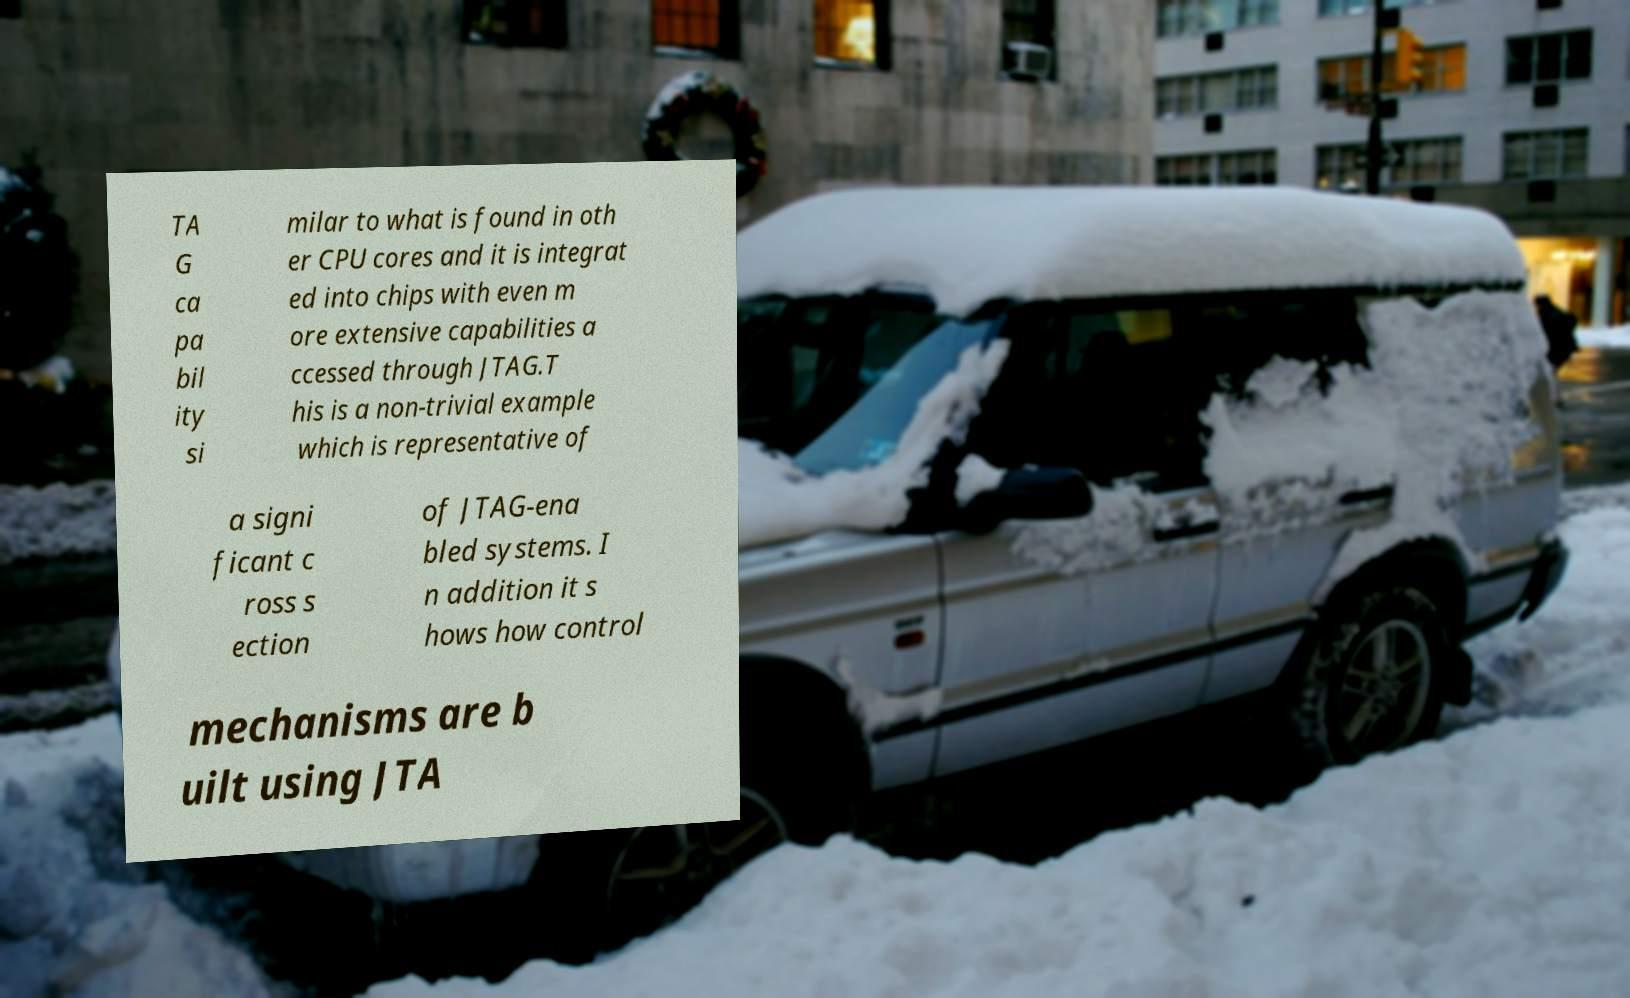Could you assist in decoding the text presented in this image and type it out clearly? TA G ca pa bil ity si milar to what is found in oth er CPU cores and it is integrat ed into chips with even m ore extensive capabilities a ccessed through JTAG.T his is a non-trivial example which is representative of a signi ficant c ross s ection of JTAG-ena bled systems. I n addition it s hows how control mechanisms are b uilt using JTA 